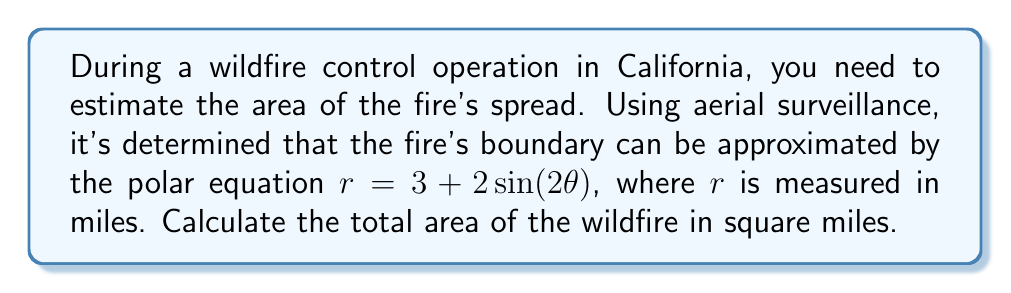Can you solve this math problem? To solve this problem, we need to use the formula for area in polar coordinates:

$$A = \frac{1}{2}\int_{0}^{2\pi} r^2 d\theta$$

Given equation: $r = 3 + 2\sin(2\theta)$

Step 1: Square the radius function:
$$r^2 = (3 + 2\sin(2\theta))^2 = 9 + 12\sin(2\theta) + 4\sin^2(2\theta)$$

Step 2: Substitute $r^2$ into the area formula:
$$A = \frac{1}{2}\int_{0}^{2\pi} (9 + 12\sin(2\theta) + 4\sin^2(2\theta)) d\theta$$

Step 3: Integrate each term:
- $\int_{0}^{2\pi} 9 d\theta = 9\theta \Big|_{0}^{2\pi} = 18\pi$
- $\int_{0}^{2\pi} 12\sin(2\theta) d\theta = -6\cos(2\theta) \Big|_{0}^{2\pi} = 0$
- $\int_{0}^{2\pi} 4\sin^2(2\theta) d\theta = 2\theta - \sin(4\theta) \Big|_{0}^{2\pi} = 4\pi$

Step 4: Sum up the results and multiply by $\frac{1}{2}$:
$$A = \frac{1}{2}(18\pi + 0 + 4\pi) = \frac{1}{2}(22\pi) = 11\pi$$

Therefore, the total area of the wildfire is $11\pi$ square miles.
Answer: $11\pi$ square miles 